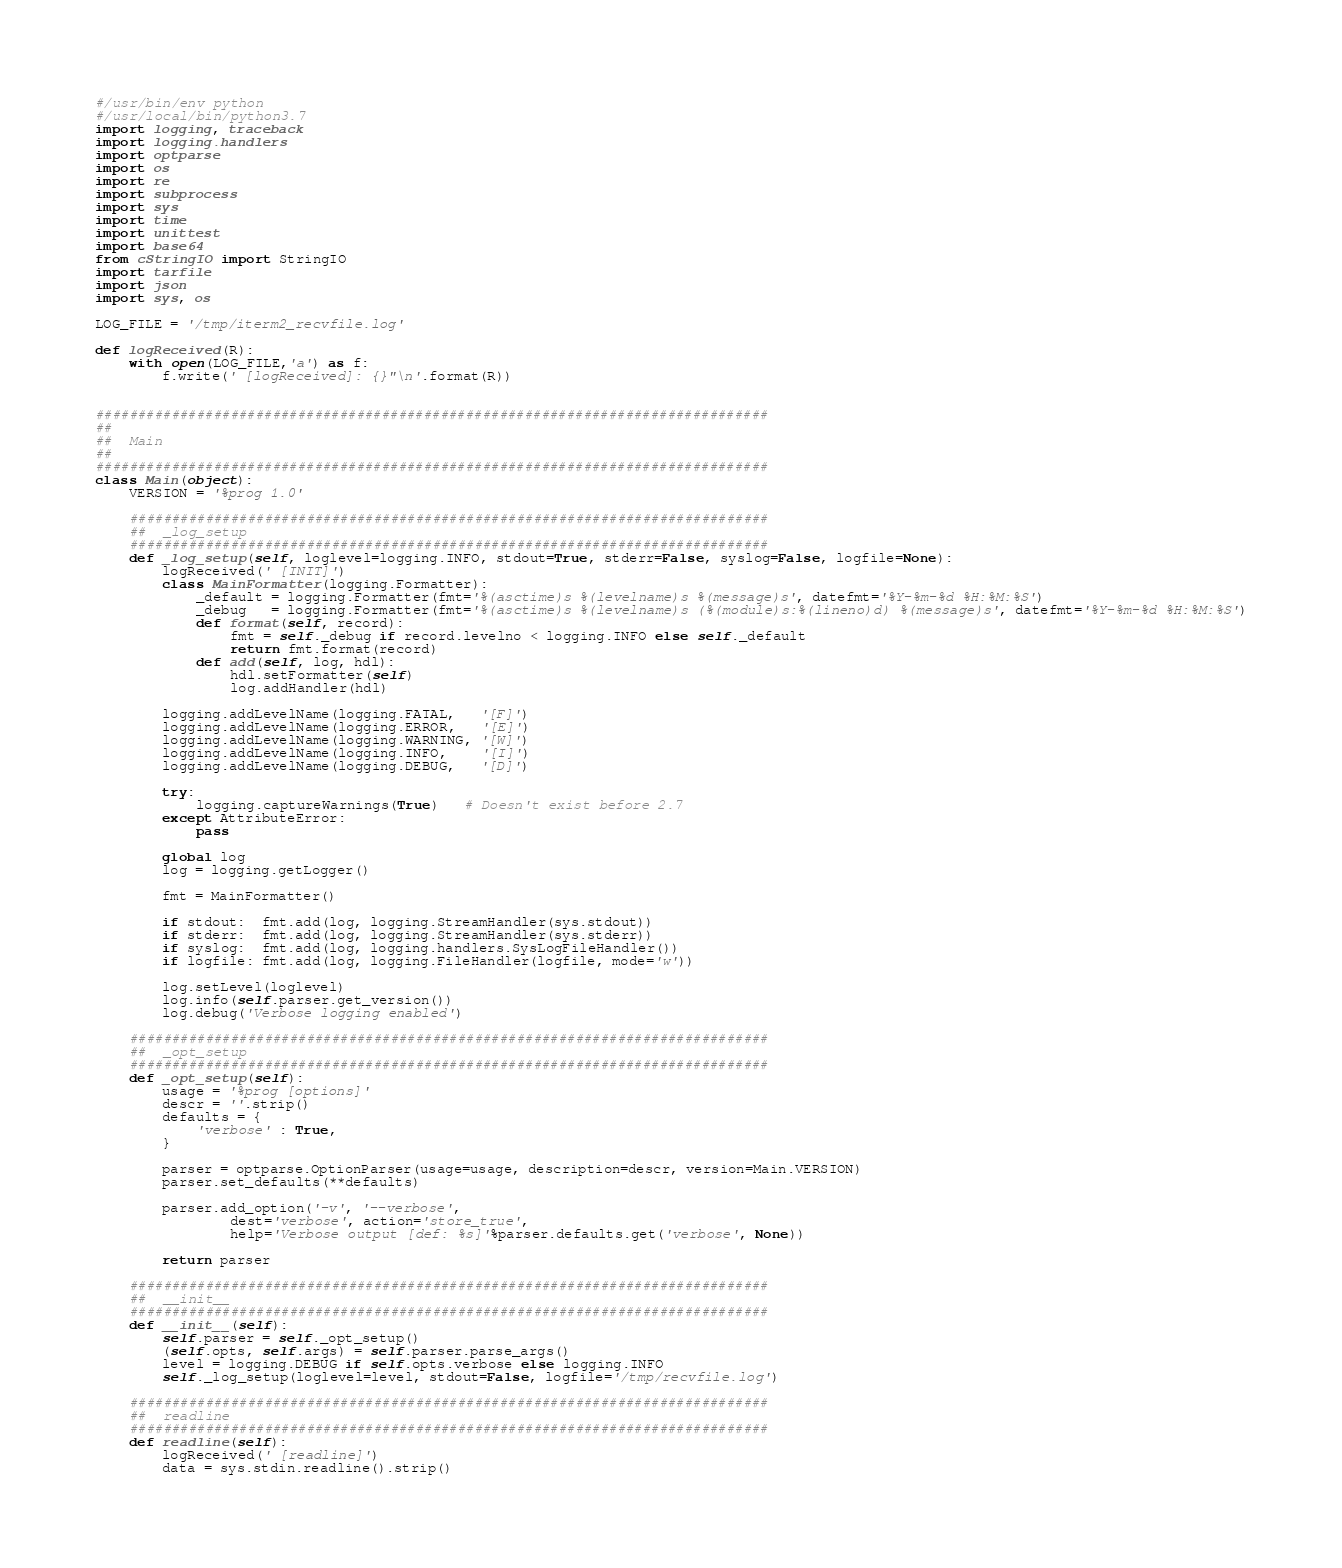<code> <loc_0><loc_0><loc_500><loc_500><_Python_>#/usr/bin/env python
#/usr/local/bin/python3.7
import logging, traceback
import logging.handlers
import optparse
import os
import re
import subprocess
import sys
import time
import unittest
import base64
from cStringIO import StringIO
import tarfile
import json
import sys, os

LOG_FILE = '/tmp/iterm2_recvfile.log'

def logReceived(R):
    with open(LOG_FILE,'a') as f:
        f.write(' [logReceived]: {}"\n'.format(R))


################################################################################
##
##  Main
##
################################################################################
class Main(object):
    VERSION = '%prog 1.0'

    ############################################################################
    ##  _log_setup
    ############################################################################
    def _log_setup(self, loglevel=logging.INFO, stdout=True, stderr=False, syslog=False, logfile=None):
        logReceived(' [INIT]')
        class MainFormatter(logging.Formatter):
            _default = logging.Formatter(fmt='%(asctime)s %(levelname)s %(message)s', datefmt='%Y-%m-%d %H:%M:%S')
            _debug   = logging.Formatter(fmt='%(asctime)s %(levelname)s (%(module)s:%(lineno)d) %(message)s', datefmt='%Y-%m-%d %H:%M:%S')
            def format(self, record):
                fmt = self._debug if record.levelno < logging.INFO else self._default
                return fmt.format(record)
            def add(self, log, hdl):
                hdl.setFormatter(self)
                log.addHandler(hdl)

        logging.addLevelName(logging.FATAL,   '[F]')
        logging.addLevelName(logging.ERROR,   '[E]')
        logging.addLevelName(logging.WARNING, '[W]')
        logging.addLevelName(logging.INFO,    '[I]')
        logging.addLevelName(logging.DEBUG,   '[D]')

        try:
            logging.captureWarnings(True)   # Doesn't exist before 2.7
        except AttributeError:
            pass

        global log
        log = logging.getLogger()

        fmt = MainFormatter()

        if stdout:  fmt.add(log, logging.StreamHandler(sys.stdout))
        if stderr:  fmt.add(log, logging.StreamHandler(sys.stderr))
        if syslog:  fmt.add(log, logging.handlers.SysLogFileHandler())
        if logfile: fmt.add(log, logging.FileHandler(logfile, mode='w'))

        log.setLevel(loglevel)
        log.info(self.parser.get_version())
        log.debug('Verbose logging enabled')

    ############################################################################
    ##  _opt_setup
    ############################################################################
    def _opt_setup(self):
        usage = '%prog [options]'
        descr = ''.strip()
        defaults = {
            'verbose' : True,
        }

        parser = optparse.OptionParser(usage=usage, description=descr, version=Main.VERSION)
        parser.set_defaults(**defaults)

        parser.add_option('-v', '--verbose',
                dest='verbose', action='store_true',
                help='Verbose output [def: %s]'%parser.defaults.get('verbose', None))

        return parser

    ############################################################################
    ##  __init__
    ############################################################################
    def __init__(self):
        self.parser = self._opt_setup()
        (self.opts, self.args) = self.parser.parse_args()
        level = logging.DEBUG if self.opts.verbose else logging.INFO
        self._log_setup(loglevel=level, stdout=False, logfile='/tmp/recvfile.log')

    ############################################################################
    ##  readline
    ############################################################################
    def readline(self):
        logReceived(' [readline]')
        data = sys.stdin.readline().strip()</code> 